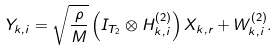Convert formula to latex. <formula><loc_0><loc_0><loc_500><loc_500>Y _ { k , i } = \sqrt { \frac { \rho } { M } } \left ( I _ { T _ { 2 } } \otimes H _ { k , i } ^ { ( 2 ) } \right ) X _ { k , r } + W _ { k , i } ^ { ( 2 ) } .</formula> 